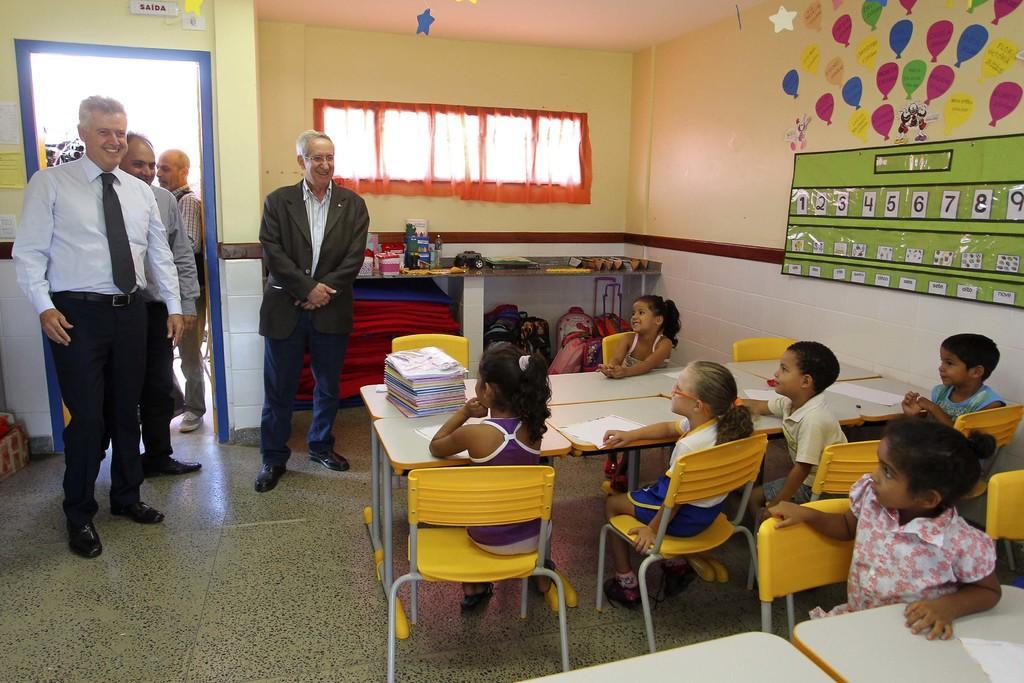Describe this image in one or two sentences. Picture of a classroom. Childrens are sitting on a chairs. On this table there are books and papers. These persons are standing near this door. This is window with curtain. On wall there are posters. On this table there are things. 